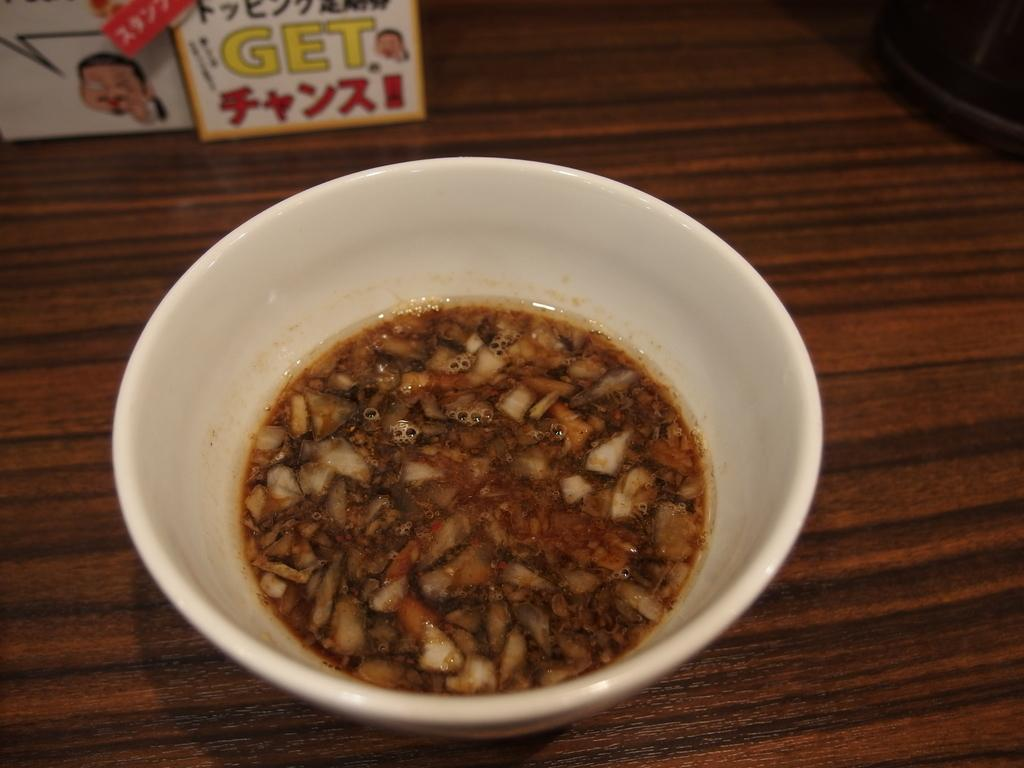What color is the bowl that is on the table in the image? The bowl on the table is white. What is inside the white bowl? There is food in the white bowl. What else can be seen on the table besides the white bowl? There are other objects on the table. What type of marble is visible on the table in the image? There is no marble present in the image; it features a white bowl with food and other objects on the table. 